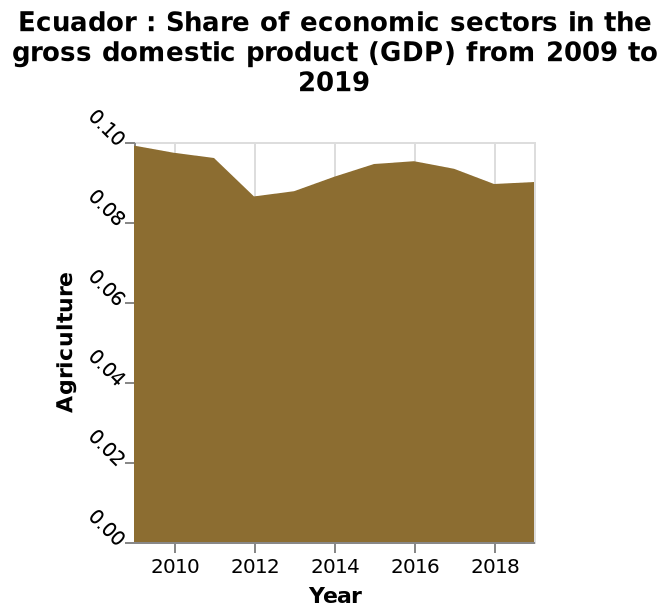<image>
What information does the area diagram provide about Ecuador? The area diagram provides insights into the share of economic sectors in Ecuador's GDP over a 10-year period from 2009 to 2019, with a focus on the agricultural sector. When did the decrease in the data start?  The decrease in the data started just before 2012. What is the subject of this area diagram?  The area diagram is about the share of economic sectors in the gross domestic product (GDP) of Ecuador from 2009 to 2019. At what point did the decrease in data plateau? The decrease in data plateaued at the start of 2018. What does the x-axis represent in this diagram?  The x-axis represents the years from 2010 to 2018, indicating the timeline of the data. 